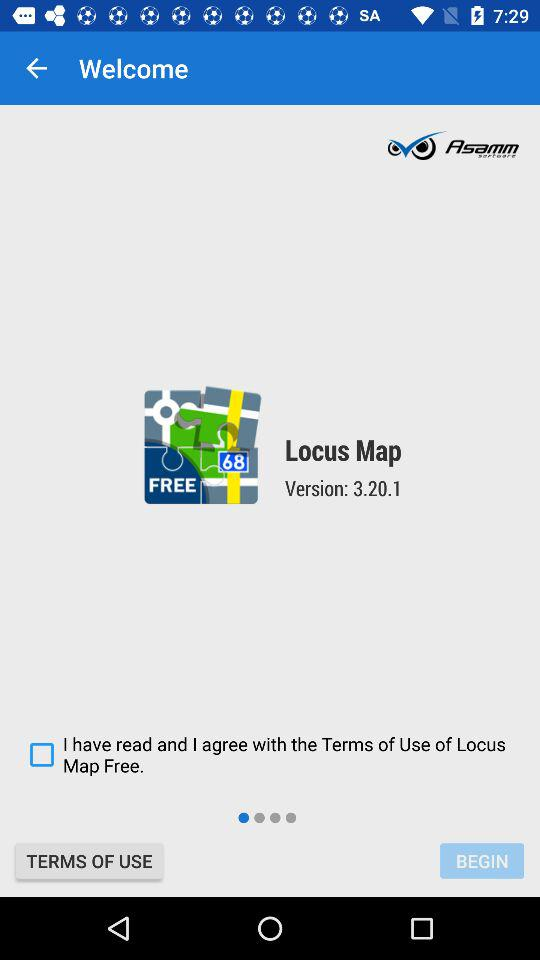What's the current version of the application "Locus Map"? The current version of the application is 3.20.1. 